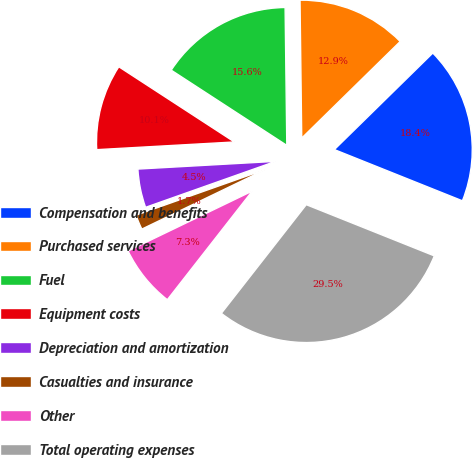Convert chart to OTSL. <chart><loc_0><loc_0><loc_500><loc_500><pie_chart><fcel>Compensation and benefits<fcel>Purchased services<fcel>Fuel<fcel>Equipment costs<fcel>Depreciation and amortization<fcel>Casualties and insurance<fcel>Other<fcel>Total operating expenses<nl><fcel>18.4%<fcel>12.85%<fcel>15.62%<fcel>10.07%<fcel>4.52%<fcel>1.74%<fcel>7.29%<fcel>29.5%<nl></chart> 